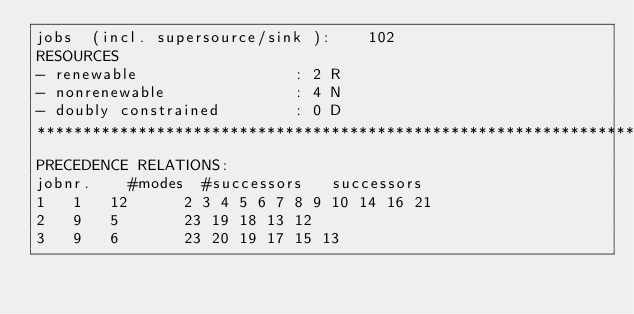Convert code to text. <code><loc_0><loc_0><loc_500><loc_500><_ObjectiveC_>jobs  (incl. supersource/sink ):	102
RESOURCES
- renewable                 : 2 R
- nonrenewable              : 4 N
- doubly constrained        : 0 D
************************************************************************
PRECEDENCE RELATIONS:
jobnr.    #modes  #successors   successors
1	1	12		2 3 4 5 6 7 8 9 10 14 16 21 
2	9	5		23 19 18 13 12 
3	9	6		23 20 19 17 15 13 </code> 